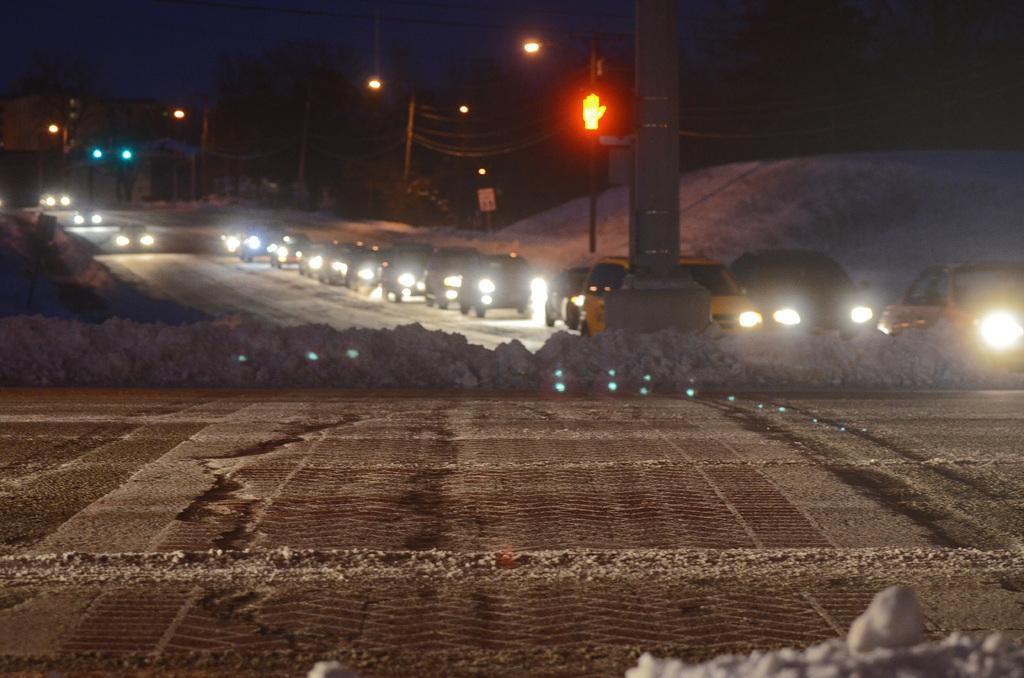Describe this image in one or two sentences. In this image there is a mud road in front of that there are some poles and cars riding on the road. 